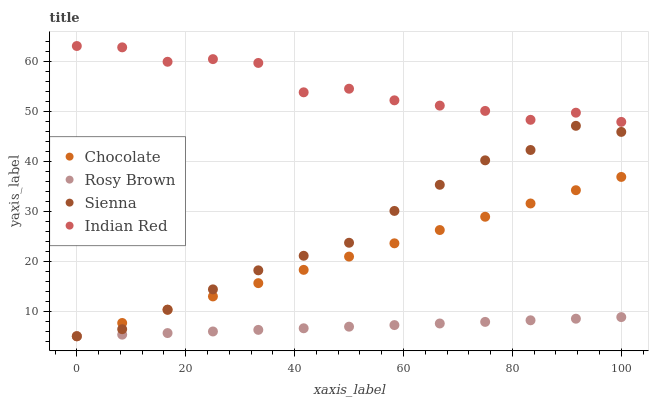Does Rosy Brown have the minimum area under the curve?
Answer yes or no. Yes. Does Indian Red have the maximum area under the curve?
Answer yes or no. Yes. Does Indian Red have the minimum area under the curve?
Answer yes or no. No. Does Rosy Brown have the maximum area under the curve?
Answer yes or no. No. Is Rosy Brown the smoothest?
Answer yes or no. Yes. Is Indian Red the roughest?
Answer yes or no. Yes. Is Indian Red the smoothest?
Answer yes or no. No. Is Rosy Brown the roughest?
Answer yes or no. No. Does Sienna have the lowest value?
Answer yes or no. Yes. Does Indian Red have the lowest value?
Answer yes or no. No. Does Indian Red have the highest value?
Answer yes or no. Yes. Does Rosy Brown have the highest value?
Answer yes or no. No. Is Sienna less than Indian Red?
Answer yes or no. Yes. Is Indian Red greater than Rosy Brown?
Answer yes or no. Yes. Does Sienna intersect Rosy Brown?
Answer yes or no. Yes. Is Sienna less than Rosy Brown?
Answer yes or no. No. Is Sienna greater than Rosy Brown?
Answer yes or no. No. Does Sienna intersect Indian Red?
Answer yes or no. No. 